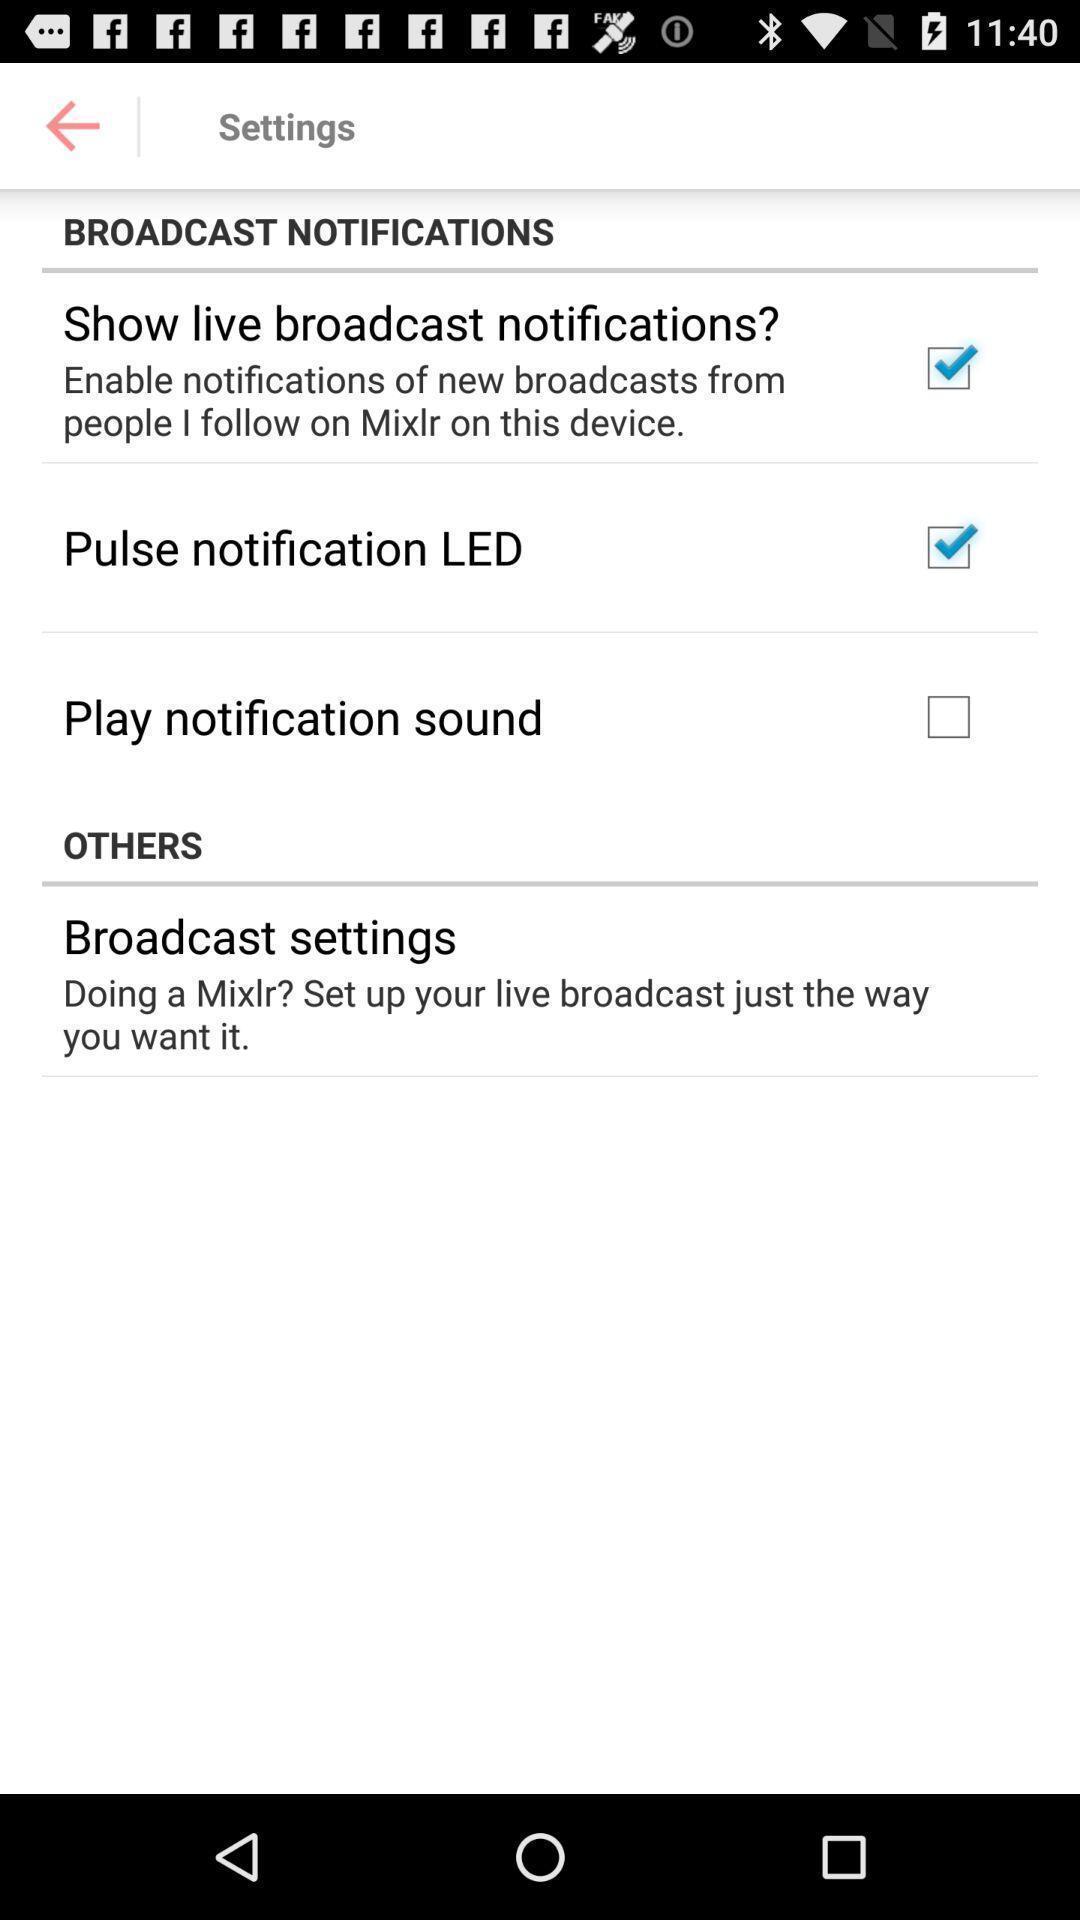Tell me what you see in this picture. Setting page displayed. 